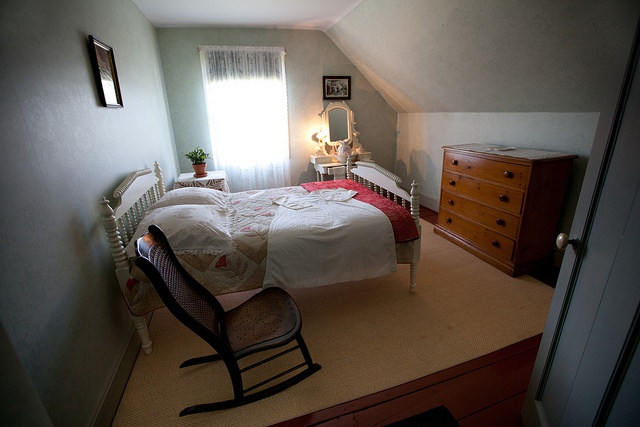Describe the objects in this image and their specific colors. I can see bed in black, gray, and darkgray tones, chair in black, gray, and maroon tones, and potted plant in black, maroon, gray, and olive tones in this image. 